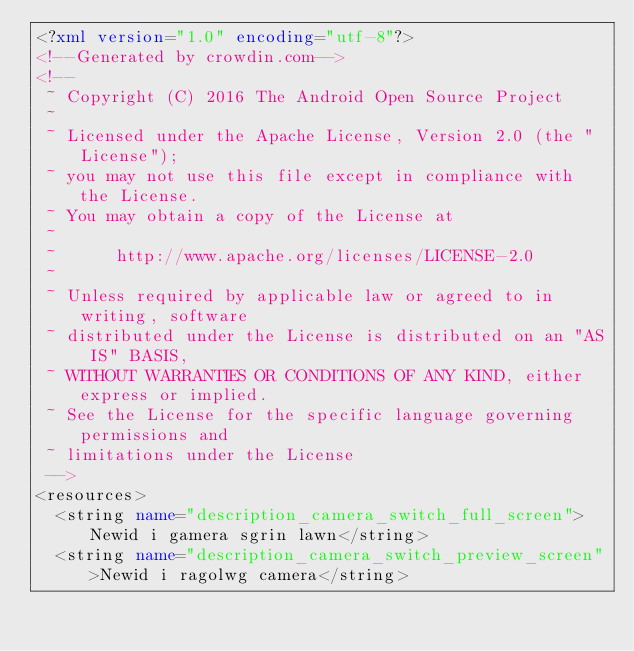Convert code to text. <code><loc_0><loc_0><loc_500><loc_500><_XML_><?xml version="1.0" encoding="utf-8"?>
<!--Generated by crowdin.com-->
<!--
 ~ Copyright (C) 2016 The Android Open Source Project
 ~
 ~ Licensed under the Apache License, Version 2.0 (the "License");
 ~ you may not use this file except in compliance with the License.
 ~ You may obtain a copy of the License at
 ~
 ~      http://www.apache.org/licenses/LICENSE-2.0
 ~
 ~ Unless required by applicable law or agreed to in writing, software
 ~ distributed under the License is distributed on an "AS IS" BASIS,
 ~ WITHOUT WARRANTIES OR CONDITIONS OF ANY KIND, either express or implied.
 ~ See the License for the specific language governing permissions and
 ~ limitations under the License
 -->
<resources>
  <string name="description_camera_switch_full_screen">Newid i gamera sgrin lawn</string>
  <string name="description_camera_switch_preview_screen">Newid i ragolwg camera</string></code> 